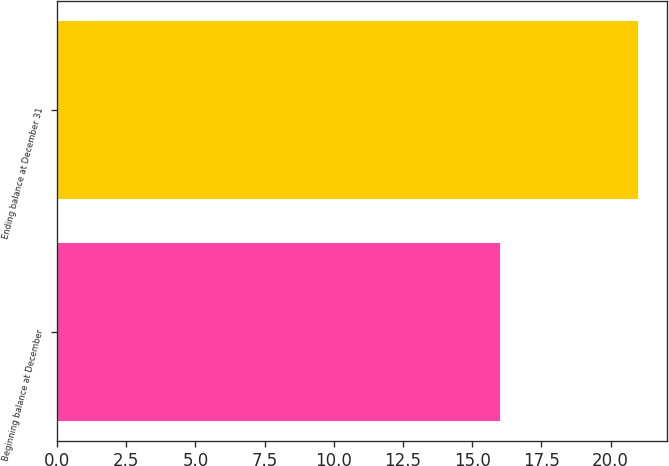<chart> <loc_0><loc_0><loc_500><loc_500><bar_chart><fcel>Beginning balance at December<fcel>Ending balance at December 31<nl><fcel>16<fcel>21<nl></chart> 